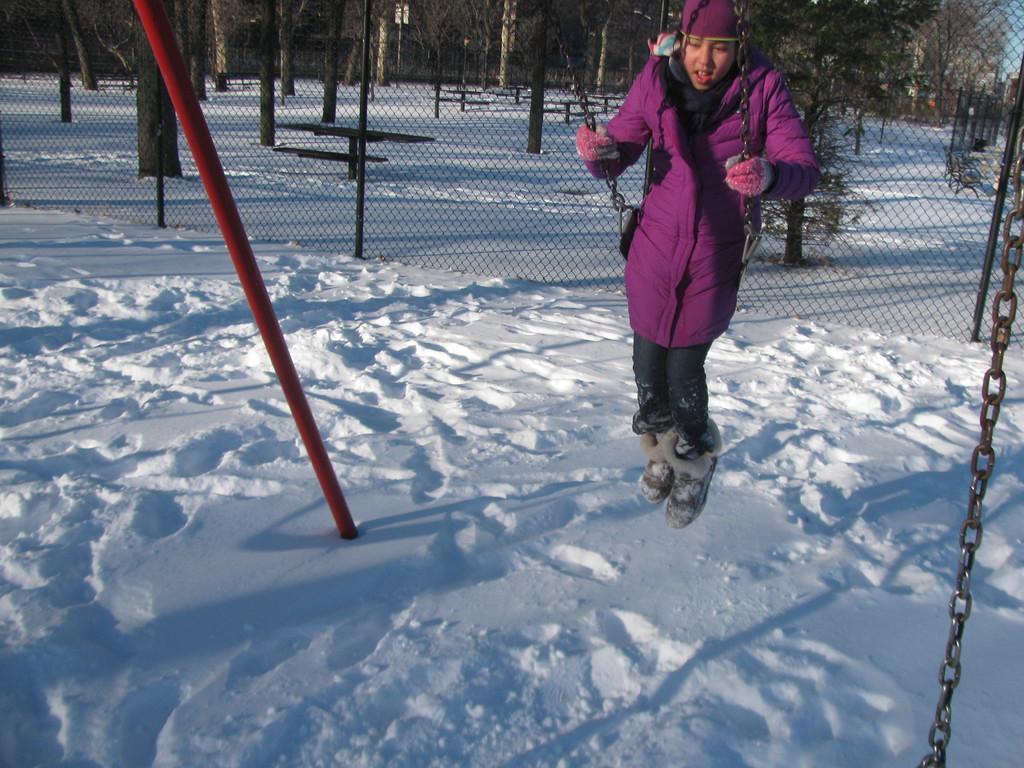Please provide a concise description of this image. In this image we can see a person wearing coat, cap and gloves is sitting in a cradle. To the left side we can see a pole placed in the snow. To the right side, we can see a chain. In the background, we can see a fence and a group of trees. 